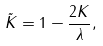Convert formula to latex. <formula><loc_0><loc_0><loc_500><loc_500>\tilde { K } = 1 - \frac { 2 K } { \lambda } ,</formula> 